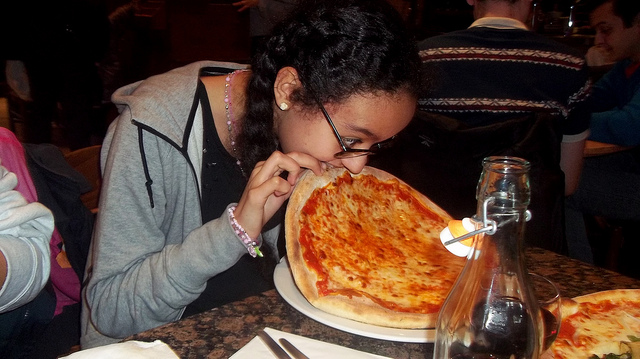<image>Is this woman blowing her nose, caught in food, or trying to hide? I am not sure. The woman could be either eating or caught in food. Is this woman blowing her nose, caught in food, or trying to hide? It is ambiguous whether this woman is blowing her nose, caught in food, or trying to hide. She can be seen both eating and caught in food. 